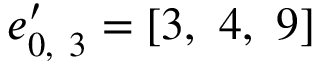Convert formula to latex. <formula><loc_0><loc_0><loc_500><loc_500>e _ { 0 , \ 3 } ^ { \prime } = \left [ 3 , \ 4 , \ 9 \right ]</formula> 